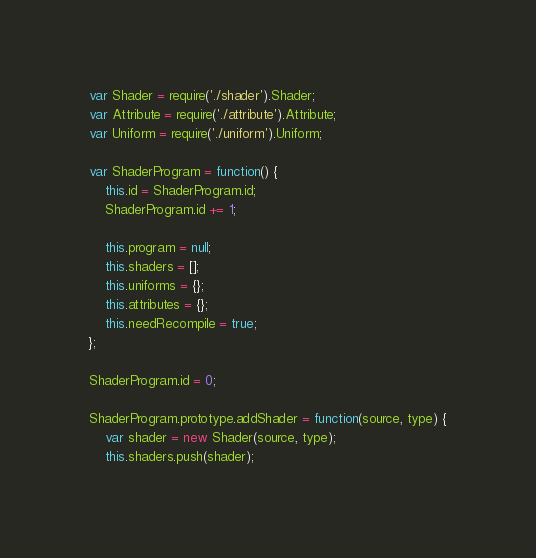Convert code to text. <code><loc_0><loc_0><loc_500><loc_500><_JavaScript_>var Shader = require('./shader').Shader;
var Attribute = require('./attribute').Attribute;
var Uniform = require('./uniform').Uniform;

var ShaderProgram = function() {
    this.id = ShaderProgram.id;
    ShaderProgram.id += 1;

    this.program = null;
    this.shaders = [];
    this.uniforms = {};
    this.attributes = {};
    this.needRecompile = true;
};

ShaderProgram.id = 0;

ShaderProgram.prototype.addShader = function(source, type) {
    var shader = new Shader(source, type);
    this.shaders.push(shader);</code> 